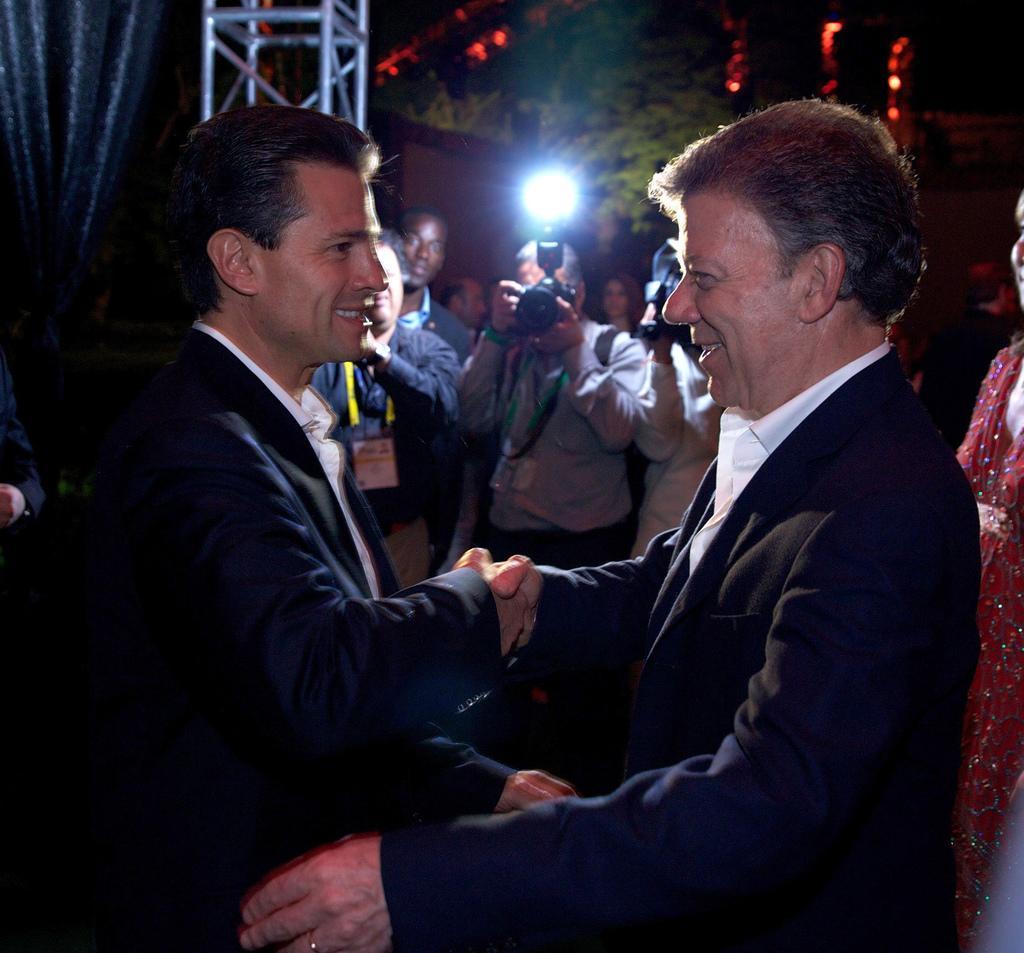Could you give a brief overview of what you see in this image? As we can see in the image there are few people here and there, camera and trees. The image is little dark. 